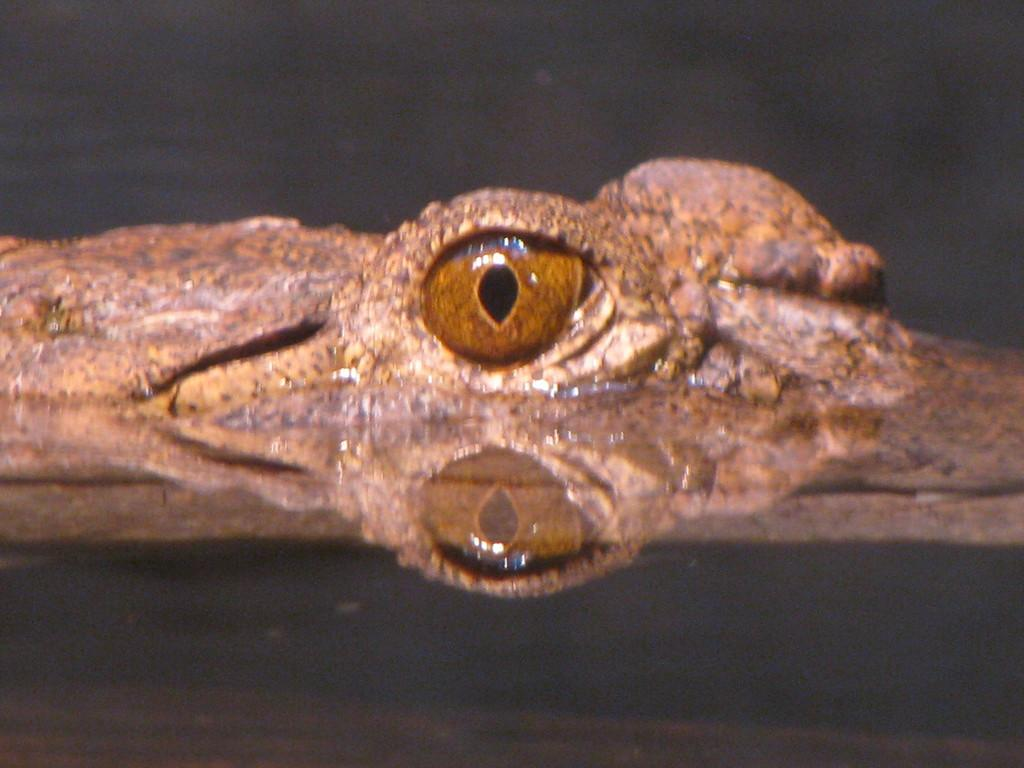What is visible in the image? There is water visible in the image. What type of animal can be seen in the image? There is a part of a reptile in the image. Can you describe any specific features of the reptile? The reptile has an eye. What type of wish can be granted by the water in the image? There is no mention of wishes or granting them in the image. The image only shows water and a part of a reptile. 